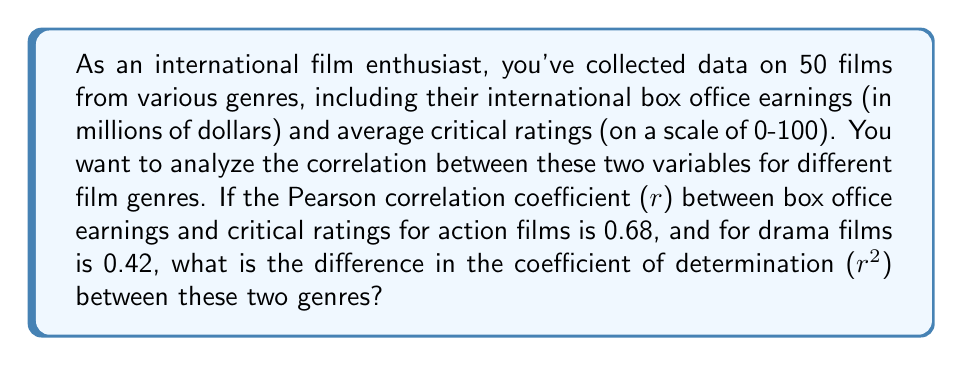What is the answer to this math problem? To solve this problem, we need to understand the relationship between the Pearson correlation coefficient (r) and the coefficient of determination (r²). The coefficient of determination is simply the square of the correlation coefficient.

For action films:
$r_{action} = 0.68$
$r^2_{action} = (0.68)^2 = 0.4624$

For drama films:
$r_{drama} = 0.42$
$r^2_{drama} = (0.42)^2 = 0.1764$

To find the difference in the coefficient of determination between these two genres, we subtract:

$\text{Difference} = r^2_{action} - r^2_{drama} = 0.4624 - 0.1764 = 0.2860$

This value can be interpreted as the difference in the proportion of variance in box office earnings that can be explained by critical ratings between action and drama films.
Answer: The difference in the coefficient of determination (r²) between action and drama films is 0.2860. 